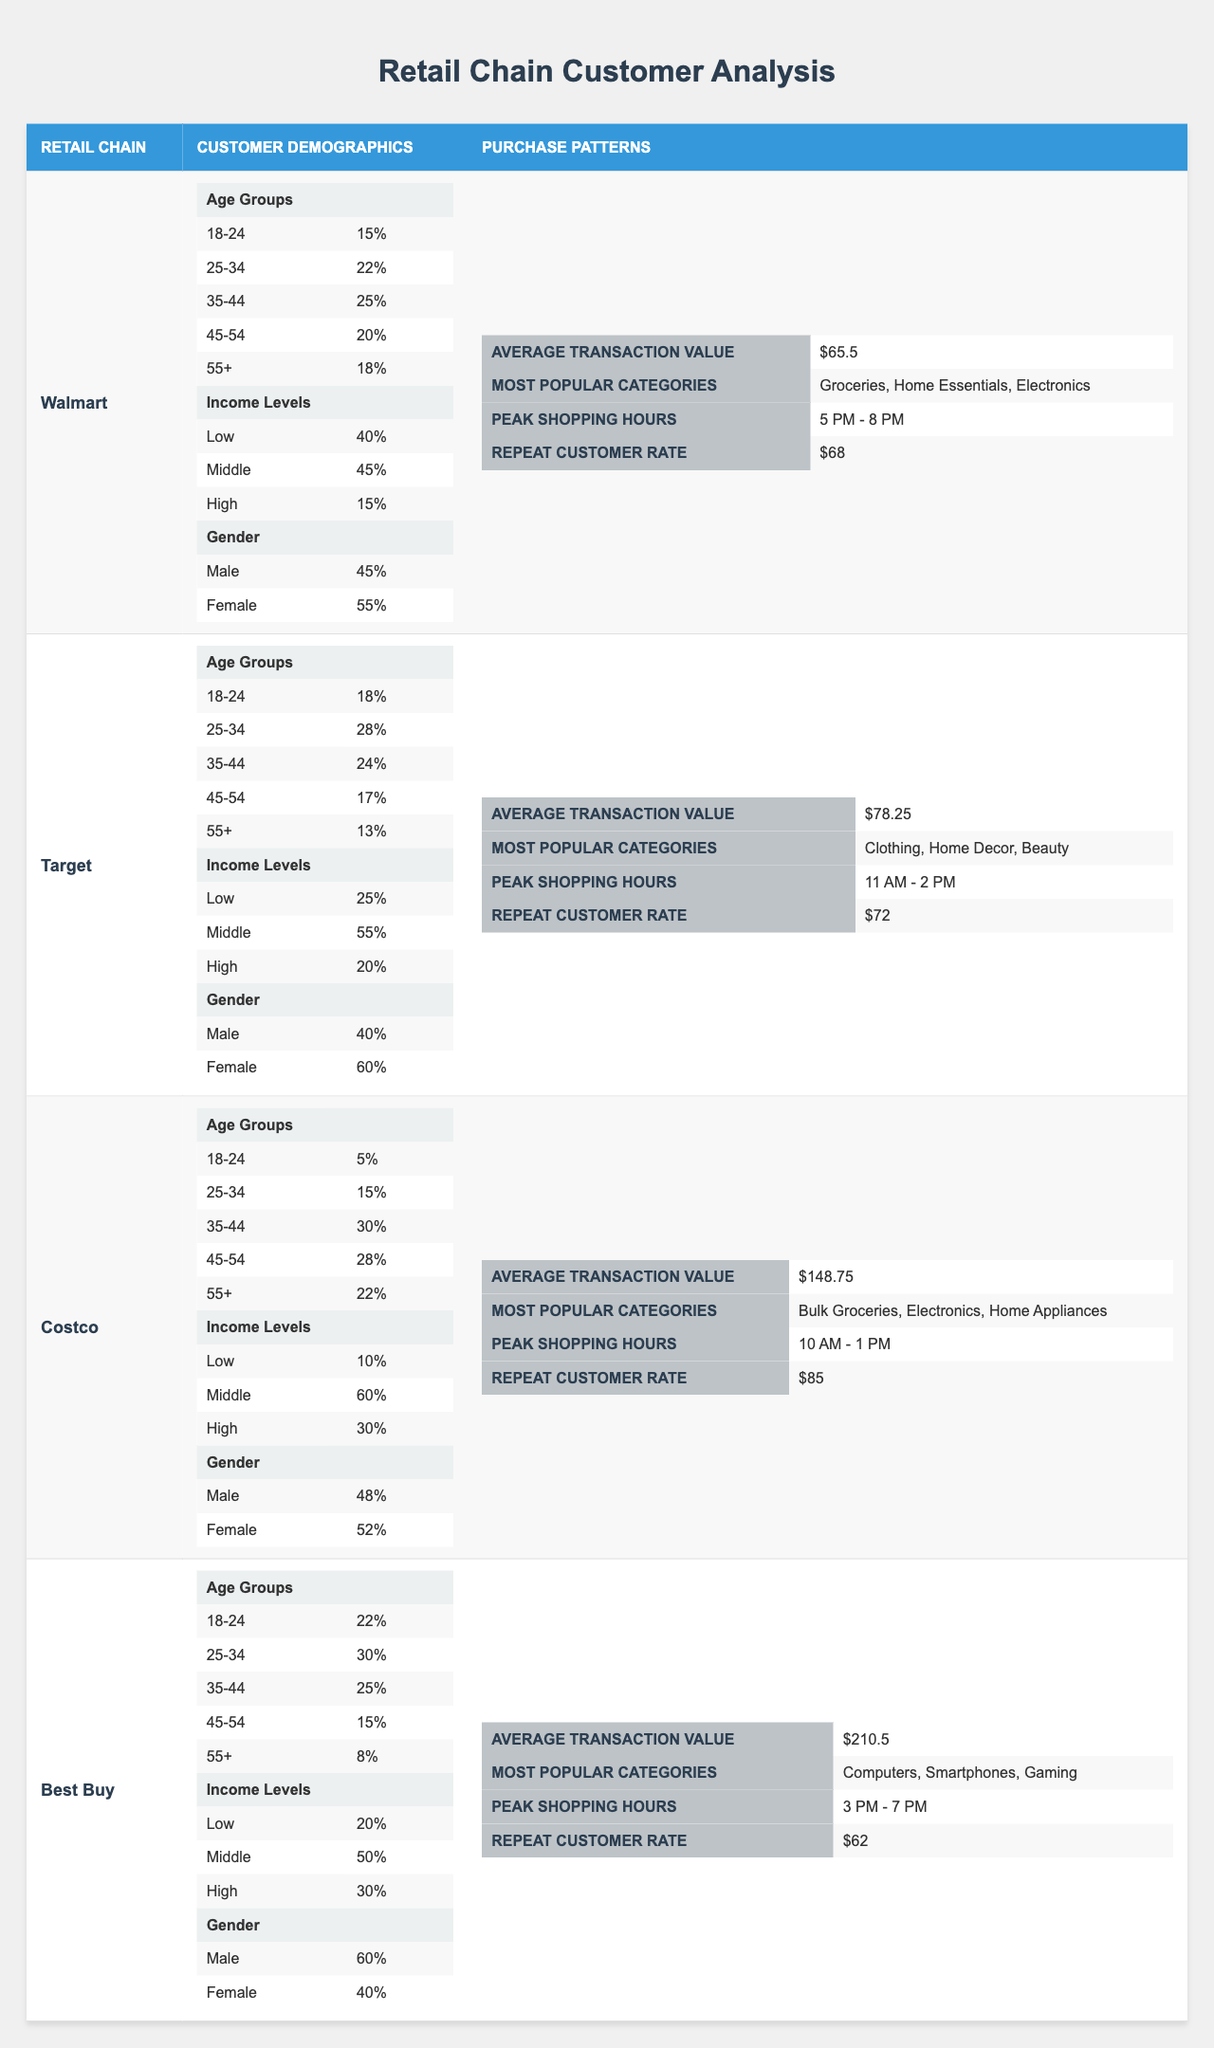What is the most popular purchase category at Walmart? The table indicates that the most popular purchase categories are listed for each retail chain. For Walmart, the most popular categories are "Groceries," "Home Essentials," and "Electronics."
Answer: Groceries, Home Essentials, Electronics How much is the average transaction value at Target? The average transaction value is directly provided in the Purchase Patterns section for Target, which states it is $78.25.
Answer: $78.25 Which retail chain has the highest repeat customer rate? By comparing the repeat customer rates listed in the Purchase Patterns for each retail chain, Costco has the highest rate at 85.
Answer: Costco What percentage of male customers shop at Best Buy? The table shows the gender demographics for Best Buy, indicating that 60% of customers are male.
Answer: 60% How does the average transaction value at Walmart compare to that at Costco? The average transaction value at Walmart is $65.50 and at Costco, it is significantly higher at $148.75. The difference is $148.75 - $65.50 = $83.25.
Answer: $83.25 True or False: Target has a higher percentage of female customers than Walmart. In the Customer Demographics for Target, 60% of customers are female and for Walmart, it is 55%. Since 60% > 55%, the statement is true.
Answer: True Which age group has the highest representation at Costco? The age group percentages are provided for each retail chain, and for Costco, the age group "35-44" has the highest representation at 30%.
Answer: 35-44 What is the average transaction value for the retail chains listed? To find the average transaction value, we sum the average transaction values of all chains ($65.50 + $78.25 + $148.75 + $210.50) which equals $503. Aggregate that over 4 chains gives $503/4 = $125.75.
Answer: $125.75 In which retail chain are customers aged 55+ most represented? Looking at the age groups across all retail chains, customers aged 55 and older make up 22% in Costco, which is the highest among the listed chains.
Answer: Costco What percentage of Target's customers are from the low-income level demographic? For Target, the percentage of customers in the low-income level demographic is specifically indicated as 25%.
Answer: 25% 